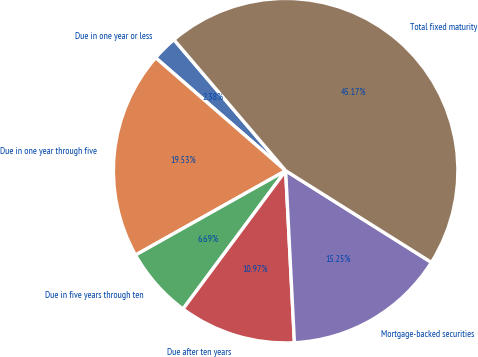<chart> <loc_0><loc_0><loc_500><loc_500><pie_chart><fcel>Due in one year or less<fcel>Due in one year through five<fcel>Due in five years through ten<fcel>Due after ten years<fcel>Mortgage-backed securities<fcel>Total fixed maturity<nl><fcel>2.38%<fcel>19.53%<fcel>6.69%<fcel>10.97%<fcel>15.25%<fcel>45.17%<nl></chart> 